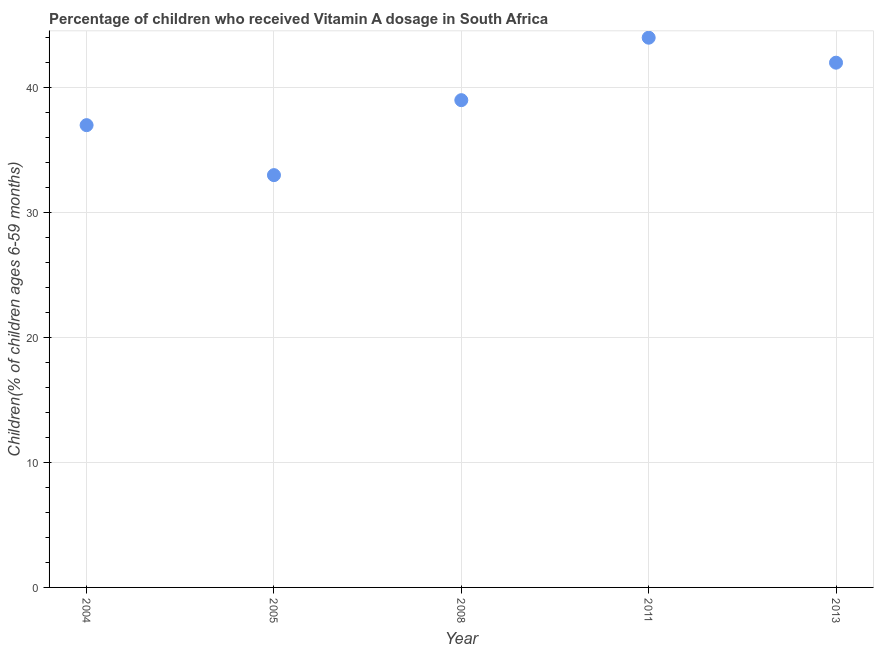What is the vitamin a supplementation coverage rate in 2005?
Your answer should be very brief. 33. Across all years, what is the maximum vitamin a supplementation coverage rate?
Ensure brevity in your answer.  44. Across all years, what is the minimum vitamin a supplementation coverage rate?
Make the answer very short. 33. In which year was the vitamin a supplementation coverage rate minimum?
Provide a succinct answer. 2005. What is the sum of the vitamin a supplementation coverage rate?
Keep it short and to the point. 195. What is the difference between the vitamin a supplementation coverage rate in 2008 and 2013?
Make the answer very short. -3. What is the ratio of the vitamin a supplementation coverage rate in 2005 to that in 2008?
Ensure brevity in your answer.  0.85. Is the difference between the vitamin a supplementation coverage rate in 2004 and 2005 greater than the difference between any two years?
Make the answer very short. No. What is the difference between the highest and the second highest vitamin a supplementation coverage rate?
Your answer should be compact. 2. What is the difference between the highest and the lowest vitamin a supplementation coverage rate?
Your answer should be compact. 11. In how many years, is the vitamin a supplementation coverage rate greater than the average vitamin a supplementation coverage rate taken over all years?
Your answer should be very brief. 2. How many dotlines are there?
Keep it short and to the point. 1. What is the difference between two consecutive major ticks on the Y-axis?
Keep it short and to the point. 10. Are the values on the major ticks of Y-axis written in scientific E-notation?
Provide a succinct answer. No. What is the title of the graph?
Your response must be concise. Percentage of children who received Vitamin A dosage in South Africa. What is the label or title of the X-axis?
Ensure brevity in your answer.  Year. What is the label or title of the Y-axis?
Provide a short and direct response. Children(% of children ages 6-59 months). What is the Children(% of children ages 6-59 months) in 2005?
Give a very brief answer. 33. What is the difference between the Children(% of children ages 6-59 months) in 2004 and 2008?
Your answer should be compact. -2. What is the difference between the Children(% of children ages 6-59 months) in 2004 and 2011?
Provide a succinct answer. -7. What is the difference between the Children(% of children ages 6-59 months) in 2004 and 2013?
Make the answer very short. -5. What is the difference between the Children(% of children ages 6-59 months) in 2005 and 2008?
Your answer should be compact. -6. What is the difference between the Children(% of children ages 6-59 months) in 2005 and 2011?
Offer a very short reply. -11. What is the difference between the Children(% of children ages 6-59 months) in 2008 and 2011?
Make the answer very short. -5. What is the difference between the Children(% of children ages 6-59 months) in 2011 and 2013?
Offer a very short reply. 2. What is the ratio of the Children(% of children ages 6-59 months) in 2004 to that in 2005?
Keep it short and to the point. 1.12. What is the ratio of the Children(% of children ages 6-59 months) in 2004 to that in 2008?
Offer a very short reply. 0.95. What is the ratio of the Children(% of children ages 6-59 months) in 2004 to that in 2011?
Your answer should be very brief. 0.84. What is the ratio of the Children(% of children ages 6-59 months) in 2004 to that in 2013?
Your response must be concise. 0.88. What is the ratio of the Children(% of children ages 6-59 months) in 2005 to that in 2008?
Offer a very short reply. 0.85. What is the ratio of the Children(% of children ages 6-59 months) in 2005 to that in 2013?
Make the answer very short. 0.79. What is the ratio of the Children(% of children ages 6-59 months) in 2008 to that in 2011?
Offer a very short reply. 0.89. What is the ratio of the Children(% of children ages 6-59 months) in 2008 to that in 2013?
Your response must be concise. 0.93. What is the ratio of the Children(% of children ages 6-59 months) in 2011 to that in 2013?
Provide a succinct answer. 1.05. 